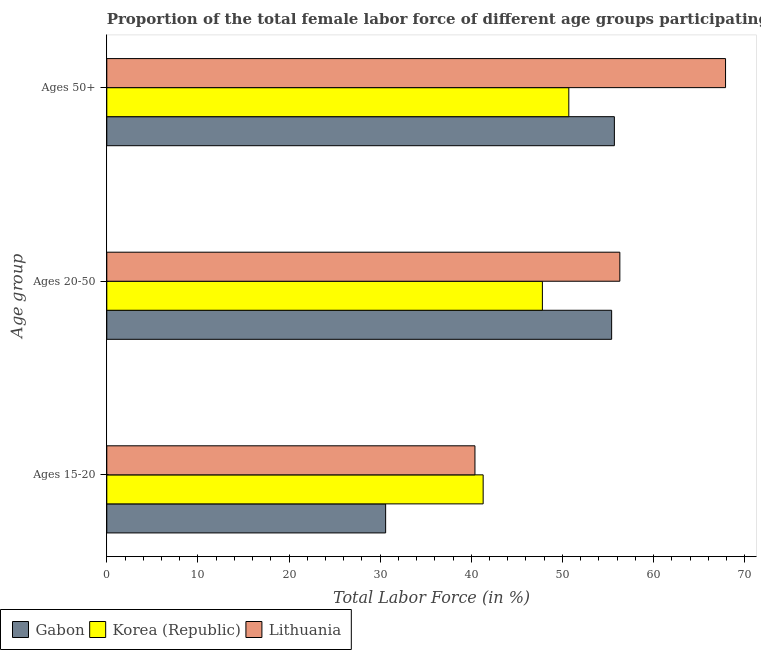Are the number of bars on each tick of the Y-axis equal?
Offer a terse response. Yes. How many bars are there on the 3rd tick from the bottom?
Your answer should be very brief. 3. What is the label of the 3rd group of bars from the top?
Offer a terse response. Ages 15-20. What is the percentage of female labor force within the age group 20-50 in Gabon?
Offer a terse response. 55.4. Across all countries, what is the maximum percentage of female labor force above age 50?
Ensure brevity in your answer.  67.9. Across all countries, what is the minimum percentage of female labor force within the age group 20-50?
Provide a succinct answer. 47.8. What is the total percentage of female labor force above age 50 in the graph?
Offer a very short reply. 174.3. What is the difference between the percentage of female labor force within the age group 15-20 in Korea (Republic) and that in Lithuania?
Offer a very short reply. 0.9. What is the difference between the percentage of female labor force within the age group 20-50 in Korea (Republic) and the percentage of female labor force above age 50 in Gabon?
Make the answer very short. -7.9. What is the average percentage of female labor force within the age group 20-50 per country?
Provide a succinct answer. 53.17. In how many countries, is the percentage of female labor force above age 50 greater than 26 %?
Give a very brief answer. 3. What is the ratio of the percentage of female labor force within the age group 20-50 in Lithuania to that in Korea (Republic)?
Your answer should be very brief. 1.18. Is the percentage of female labor force within the age group 15-20 in Lithuania less than that in Korea (Republic)?
Keep it short and to the point. Yes. What is the difference between the highest and the second highest percentage of female labor force within the age group 20-50?
Offer a very short reply. 0.9. What is the difference between the highest and the lowest percentage of female labor force within the age group 20-50?
Provide a succinct answer. 8.5. In how many countries, is the percentage of female labor force above age 50 greater than the average percentage of female labor force above age 50 taken over all countries?
Your response must be concise. 1. Is the sum of the percentage of female labor force above age 50 in Lithuania and Gabon greater than the maximum percentage of female labor force within the age group 15-20 across all countries?
Ensure brevity in your answer.  Yes. What does the 1st bar from the top in Ages 15-20 represents?
Give a very brief answer. Lithuania. What does the 3rd bar from the bottom in Ages 50+ represents?
Provide a short and direct response. Lithuania. Is it the case that in every country, the sum of the percentage of female labor force within the age group 15-20 and percentage of female labor force within the age group 20-50 is greater than the percentage of female labor force above age 50?
Make the answer very short. Yes. Are the values on the major ticks of X-axis written in scientific E-notation?
Provide a succinct answer. No. Does the graph contain any zero values?
Ensure brevity in your answer.  No. Does the graph contain grids?
Offer a terse response. No. What is the title of the graph?
Offer a terse response. Proportion of the total female labor force of different age groups participating in production in 1994. What is the label or title of the Y-axis?
Provide a short and direct response. Age group. What is the Total Labor Force (in %) in Gabon in Ages 15-20?
Your answer should be compact. 30.6. What is the Total Labor Force (in %) of Korea (Republic) in Ages 15-20?
Make the answer very short. 41.3. What is the Total Labor Force (in %) in Lithuania in Ages 15-20?
Give a very brief answer. 40.4. What is the Total Labor Force (in %) in Gabon in Ages 20-50?
Give a very brief answer. 55.4. What is the Total Labor Force (in %) in Korea (Republic) in Ages 20-50?
Offer a very short reply. 47.8. What is the Total Labor Force (in %) in Lithuania in Ages 20-50?
Your answer should be very brief. 56.3. What is the Total Labor Force (in %) in Gabon in Ages 50+?
Make the answer very short. 55.7. What is the Total Labor Force (in %) of Korea (Republic) in Ages 50+?
Give a very brief answer. 50.7. What is the Total Labor Force (in %) in Lithuania in Ages 50+?
Your answer should be very brief. 67.9. Across all Age group, what is the maximum Total Labor Force (in %) in Gabon?
Your answer should be very brief. 55.7. Across all Age group, what is the maximum Total Labor Force (in %) in Korea (Republic)?
Offer a very short reply. 50.7. Across all Age group, what is the maximum Total Labor Force (in %) of Lithuania?
Offer a terse response. 67.9. Across all Age group, what is the minimum Total Labor Force (in %) in Gabon?
Provide a short and direct response. 30.6. Across all Age group, what is the minimum Total Labor Force (in %) in Korea (Republic)?
Provide a short and direct response. 41.3. Across all Age group, what is the minimum Total Labor Force (in %) of Lithuania?
Your answer should be compact. 40.4. What is the total Total Labor Force (in %) in Gabon in the graph?
Offer a terse response. 141.7. What is the total Total Labor Force (in %) of Korea (Republic) in the graph?
Your answer should be very brief. 139.8. What is the total Total Labor Force (in %) in Lithuania in the graph?
Offer a terse response. 164.6. What is the difference between the Total Labor Force (in %) in Gabon in Ages 15-20 and that in Ages 20-50?
Your response must be concise. -24.8. What is the difference between the Total Labor Force (in %) in Korea (Republic) in Ages 15-20 and that in Ages 20-50?
Give a very brief answer. -6.5. What is the difference between the Total Labor Force (in %) in Lithuania in Ages 15-20 and that in Ages 20-50?
Offer a terse response. -15.9. What is the difference between the Total Labor Force (in %) of Gabon in Ages 15-20 and that in Ages 50+?
Ensure brevity in your answer.  -25.1. What is the difference between the Total Labor Force (in %) of Korea (Republic) in Ages 15-20 and that in Ages 50+?
Make the answer very short. -9.4. What is the difference between the Total Labor Force (in %) of Lithuania in Ages 15-20 and that in Ages 50+?
Make the answer very short. -27.5. What is the difference between the Total Labor Force (in %) of Gabon in Ages 15-20 and the Total Labor Force (in %) of Korea (Republic) in Ages 20-50?
Keep it short and to the point. -17.2. What is the difference between the Total Labor Force (in %) of Gabon in Ages 15-20 and the Total Labor Force (in %) of Lithuania in Ages 20-50?
Provide a succinct answer. -25.7. What is the difference between the Total Labor Force (in %) of Gabon in Ages 15-20 and the Total Labor Force (in %) of Korea (Republic) in Ages 50+?
Provide a succinct answer. -20.1. What is the difference between the Total Labor Force (in %) of Gabon in Ages 15-20 and the Total Labor Force (in %) of Lithuania in Ages 50+?
Offer a very short reply. -37.3. What is the difference between the Total Labor Force (in %) in Korea (Republic) in Ages 15-20 and the Total Labor Force (in %) in Lithuania in Ages 50+?
Ensure brevity in your answer.  -26.6. What is the difference between the Total Labor Force (in %) of Gabon in Ages 20-50 and the Total Labor Force (in %) of Lithuania in Ages 50+?
Ensure brevity in your answer.  -12.5. What is the difference between the Total Labor Force (in %) in Korea (Republic) in Ages 20-50 and the Total Labor Force (in %) in Lithuania in Ages 50+?
Make the answer very short. -20.1. What is the average Total Labor Force (in %) in Gabon per Age group?
Offer a terse response. 47.23. What is the average Total Labor Force (in %) of Korea (Republic) per Age group?
Make the answer very short. 46.6. What is the average Total Labor Force (in %) in Lithuania per Age group?
Your answer should be compact. 54.87. What is the difference between the Total Labor Force (in %) in Gabon and Total Labor Force (in %) in Korea (Republic) in Ages 15-20?
Offer a very short reply. -10.7. What is the difference between the Total Labor Force (in %) in Gabon and Total Labor Force (in %) in Lithuania in Ages 15-20?
Your answer should be compact. -9.8. What is the difference between the Total Labor Force (in %) in Korea (Republic) and Total Labor Force (in %) in Lithuania in Ages 15-20?
Your answer should be very brief. 0.9. What is the difference between the Total Labor Force (in %) in Gabon and Total Labor Force (in %) in Korea (Republic) in Ages 20-50?
Offer a terse response. 7.6. What is the difference between the Total Labor Force (in %) in Gabon and Total Labor Force (in %) in Korea (Republic) in Ages 50+?
Your response must be concise. 5. What is the difference between the Total Labor Force (in %) in Korea (Republic) and Total Labor Force (in %) in Lithuania in Ages 50+?
Provide a succinct answer. -17.2. What is the ratio of the Total Labor Force (in %) of Gabon in Ages 15-20 to that in Ages 20-50?
Keep it short and to the point. 0.55. What is the ratio of the Total Labor Force (in %) in Korea (Republic) in Ages 15-20 to that in Ages 20-50?
Make the answer very short. 0.86. What is the ratio of the Total Labor Force (in %) of Lithuania in Ages 15-20 to that in Ages 20-50?
Give a very brief answer. 0.72. What is the ratio of the Total Labor Force (in %) in Gabon in Ages 15-20 to that in Ages 50+?
Your answer should be compact. 0.55. What is the ratio of the Total Labor Force (in %) in Korea (Republic) in Ages 15-20 to that in Ages 50+?
Ensure brevity in your answer.  0.81. What is the ratio of the Total Labor Force (in %) of Lithuania in Ages 15-20 to that in Ages 50+?
Your response must be concise. 0.59. What is the ratio of the Total Labor Force (in %) in Gabon in Ages 20-50 to that in Ages 50+?
Offer a terse response. 0.99. What is the ratio of the Total Labor Force (in %) in Korea (Republic) in Ages 20-50 to that in Ages 50+?
Offer a terse response. 0.94. What is the ratio of the Total Labor Force (in %) in Lithuania in Ages 20-50 to that in Ages 50+?
Keep it short and to the point. 0.83. What is the difference between the highest and the second highest Total Labor Force (in %) of Gabon?
Provide a succinct answer. 0.3. What is the difference between the highest and the second highest Total Labor Force (in %) in Korea (Republic)?
Keep it short and to the point. 2.9. What is the difference between the highest and the lowest Total Labor Force (in %) of Gabon?
Provide a short and direct response. 25.1. What is the difference between the highest and the lowest Total Labor Force (in %) in Korea (Republic)?
Your answer should be very brief. 9.4. What is the difference between the highest and the lowest Total Labor Force (in %) in Lithuania?
Give a very brief answer. 27.5. 